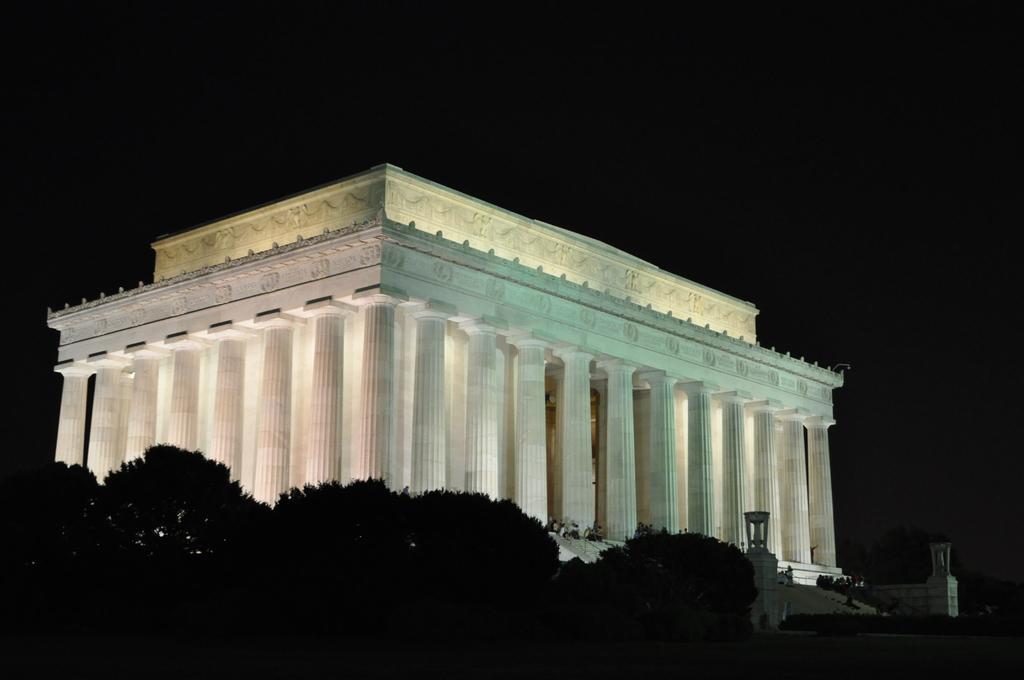Describe this image in one or two sentences. At the bottom of the image there are some trees. In the middle of the image there is a building. 